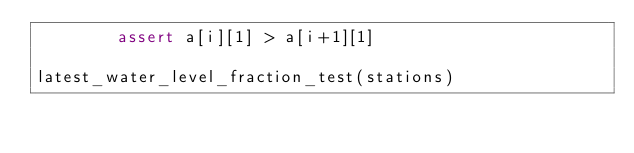<code> <loc_0><loc_0><loc_500><loc_500><_Python_>        assert a[i][1] > a[i+1][1]

latest_water_level_fraction_test(stations)</code> 